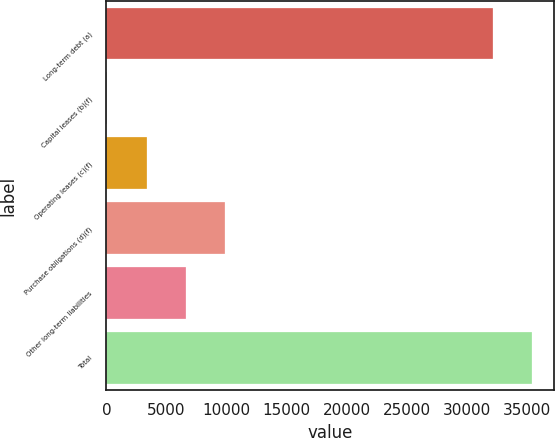<chart> <loc_0><loc_0><loc_500><loc_500><bar_chart><fcel>Long-term debt (a)<fcel>Capital leases (b)(f)<fcel>Operating leases (c)(f)<fcel>Purchase obligations (d)(f)<fcel>Other long-term liabilities<fcel>Total<nl><fcel>32195<fcel>85<fcel>3361.3<fcel>9913.9<fcel>6637.6<fcel>35471.3<nl></chart> 